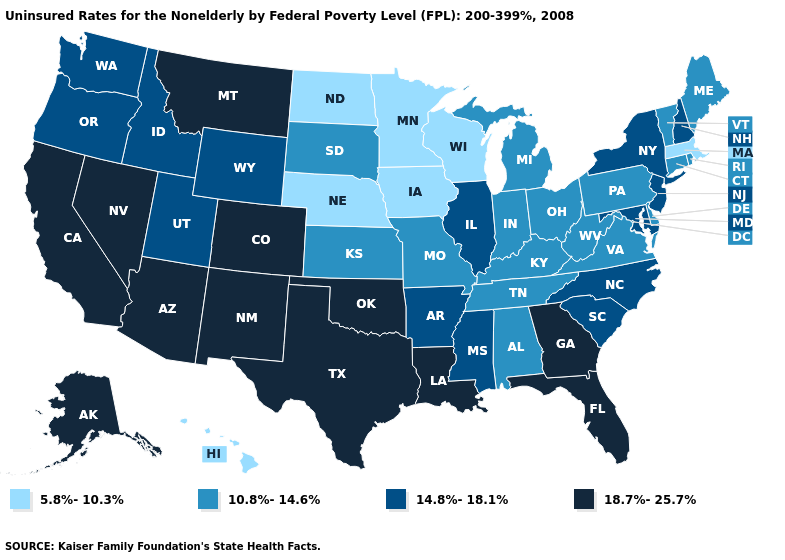Does the map have missing data?
Quick response, please. No. Name the states that have a value in the range 14.8%-18.1%?
Quick response, please. Arkansas, Idaho, Illinois, Maryland, Mississippi, New Hampshire, New Jersey, New York, North Carolina, Oregon, South Carolina, Utah, Washington, Wyoming. Name the states that have a value in the range 18.7%-25.7%?
Quick response, please. Alaska, Arizona, California, Colorado, Florida, Georgia, Louisiana, Montana, Nevada, New Mexico, Oklahoma, Texas. Among the states that border New Jersey , does Pennsylvania have the lowest value?
Short answer required. Yes. What is the highest value in the MidWest ?
Be succinct. 14.8%-18.1%. Name the states that have a value in the range 5.8%-10.3%?
Keep it brief. Hawaii, Iowa, Massachusetts, Minnesota, Nebraska, North Dakota, Wisconsin. Does the map have missing data?
Be succinct. No. Among the states that border Pennsylvania , which have the lowest value?
Keep it brief. Delaware, Ohio, West Virginia. Name the states that have a value in the range 14.8%-18.1%?
Give a very brief answer. Arkansas, Idaho, Illinois, Maryland, Mississippi, New Hampshire, New Jersey, New York, North Carolina, Oregon, South Carolina, Utah, Washington, Wyoming. Name the states that have a value in the range 14.8%-18.1%?
Answer briefly. Arkansas, Idaho, Illinois, Maryland, Mississippi, New Hampshire, New Jersey, New York, North Carolina, Oregon, South Carolina, Utah, Washington, Wyoming. What is the lowest value in states that border Georgia?
Keep it brief. 10.8%-14.6%. Name the states that have a value in the range 10.8%-14.6%?
Write a very short answer. Alabama, Connecticut, Delaware, Indiana, Kansas, Kentucky, Maine, Michigan, Missouri, Ohio, Pennsylvania, Rhode Island, South Dakota, Tennessee, Vermont, Virginia, West Virginia. Among the states that border Connecticut , which have the highest value?
Quick response, please. New York. 